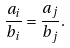Convert formula to latex. <formula><loc_0><loc_0><loc_500><loc_500>\frac { a _ { i } } { b _ { i } } = \frac { a _ { j } } { b _ { j } } .</formula> 